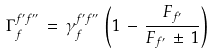Convert formula to latex. <formula><loc_0><loc_0><loc_500><loc_500>\Gamma _ { f } ^ { f ^ { \prime } f ^ { \prime \prime } } \, = \, \gamma _ { f } ^ { f ^ { \prime } f ^ { \prime \prime } } \, \left ( 1 \, - \, \frac { F _ { f ^ { \prime } } } { F _ { f ^ { \prime } } \, \pm \, 1 } \right )</formula> 